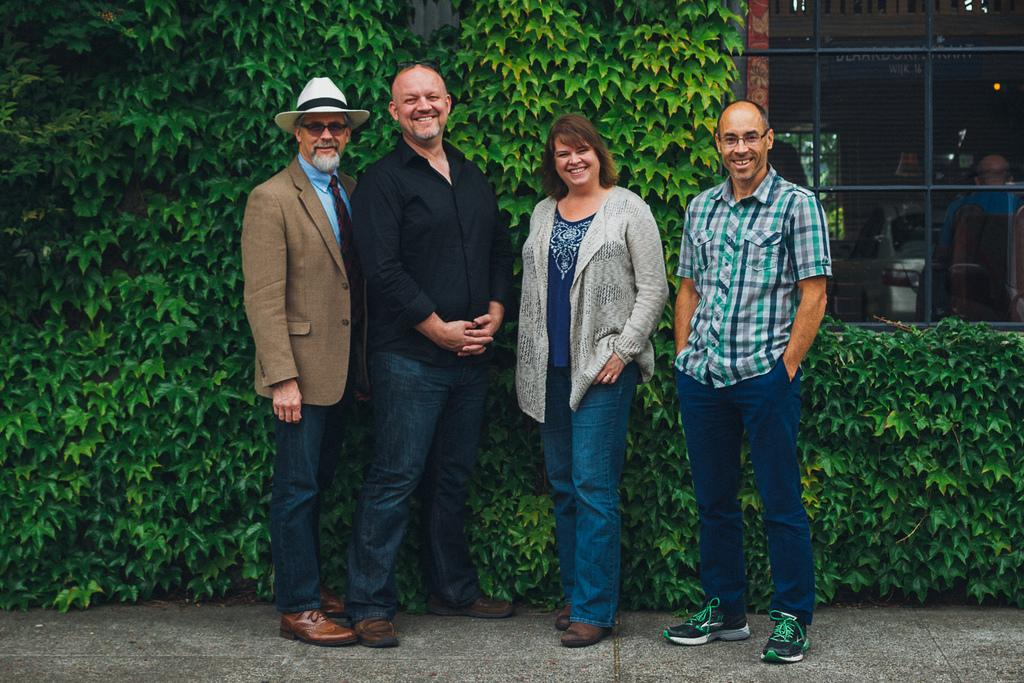How many people are in the image? There are three men and a woman in the image, making a total of four people. What are the individuals in the image doing? The individuals are standing on a platform and smiling. What can be seen in the background of the image? There are plants, a window, a person, and some objects visible in the background. Can you describe the setting of the image? The individuals are standing on a platform, which suggests they might be at an event or gathering. What type of pain is the woman experiencing in the image? There is no indication of pain in the image; the individuals are smiling. Can you see any squirrels in the image? No, there are no squirrels present in the image. 